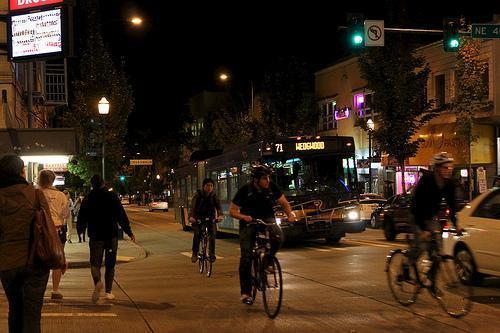How many people are in the picture?
Give a very brief answer. 6. 